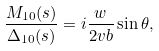Convert formula to latex. <formula><loc_0><loc_0><loc_500><loc_500>\frac { M _ { 1 0 } ( s ) } { \Delta _ { 1 0 } ( s ) } = i \frac { w } { 2 v b } \sin \theta ,</formula> 